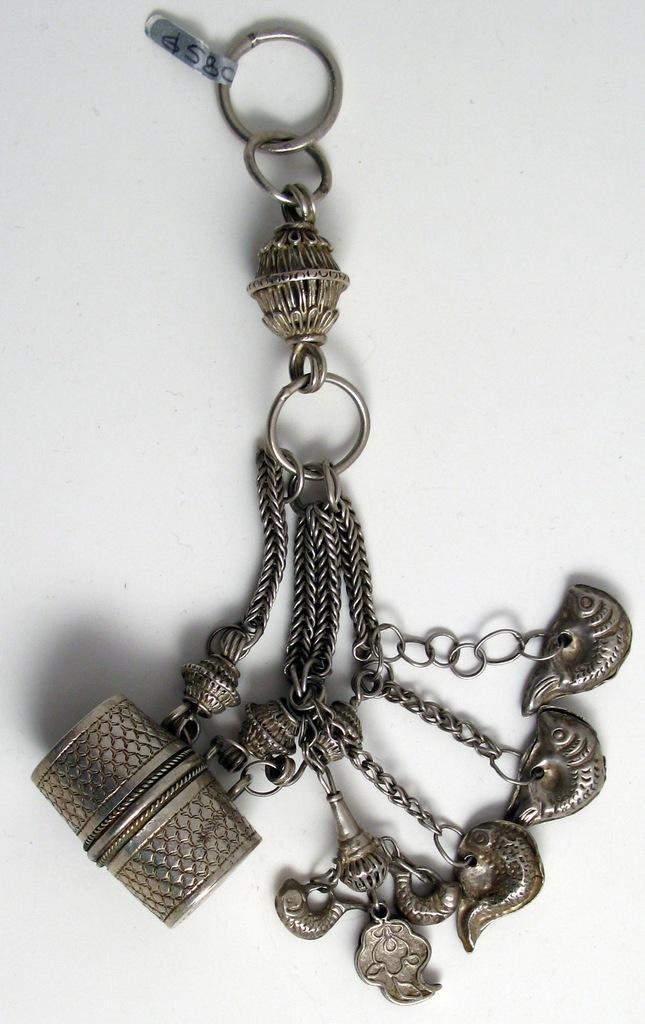In one or two sentences, can you explain what this image depicts? This is a keychain. I can see the rings, chains, artificial drum and few other things are linked to one another. This looks like a tag. The background looks white in color. 